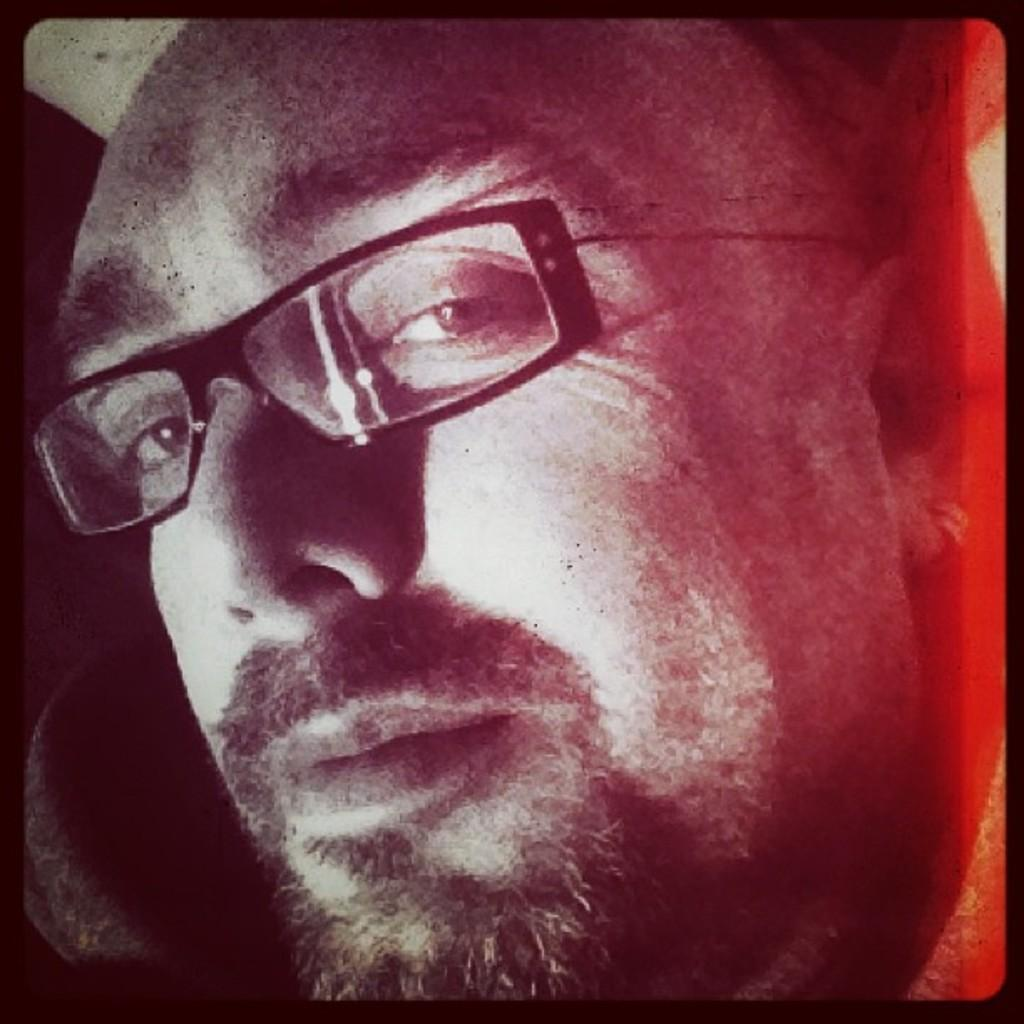What is the main subject of the image? The main subject of the image is a man. Can you describe the man's appearance in the image? The man is wearing spectacles in the image. What type of structure can be seen in the background of the image? There is no structure visible in the background of the image. What type of vegetable is the man holding in the image? The man is not holding any vegetable in the image. 